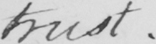What does this handwritten line say? trust .  _ 